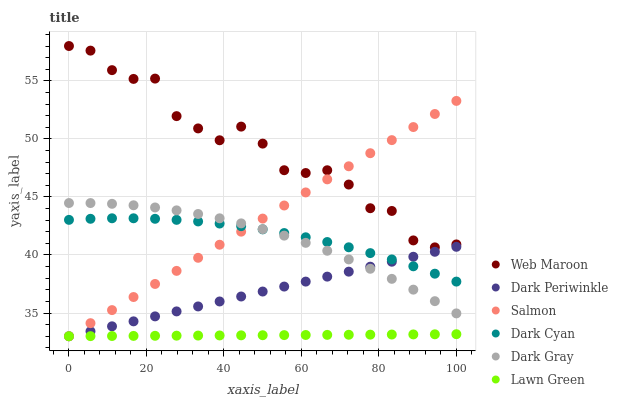Does Lawn Green have the minimum area under the curve?
Answer yes or no. Yes. Does Web Maroon have the maximum area under the curve?
Answer yes or no. Yes. Does Salmon have the minimum area under the curve?
Answer yes or no. No. Does Salmon have the maximum area under the curve?
Answer yes or no. No. Is Lawn Green the smoothest?
Answer yes or no. Yes. Is Web Maroon the roughest?
Answer yes or no. Yes. Is Salmon the smoothest?
Answer yes or no. No. Is Salmon the roughest?
Answer yes or no. No. Does Lawn Green have the lowest value?
Answer yes or no. Yes. Does Web Maroon have the lowest value?
Answer yes or no. No. Does Web Maroon have the highest value?
Answer yes or no. Yes. Does Salmon have the highest value?
Answer yes or no. No. Is Lawn Green less than Web Maroon?
Answer yes or no. Yes. Is Web Maroon greater than Lawn Green?
Answer yes or no. Yes. Does Salmon intersect Dark Gray?
Answer yes or no. Yes. Is Salmon less than Dark Gray?
Answer yes or no. No. Is Salmon greater than Dark Gray?
Answer yes or no. No. Does Lawn Green intersect Web Maroon?
Answer yes or no. No. 